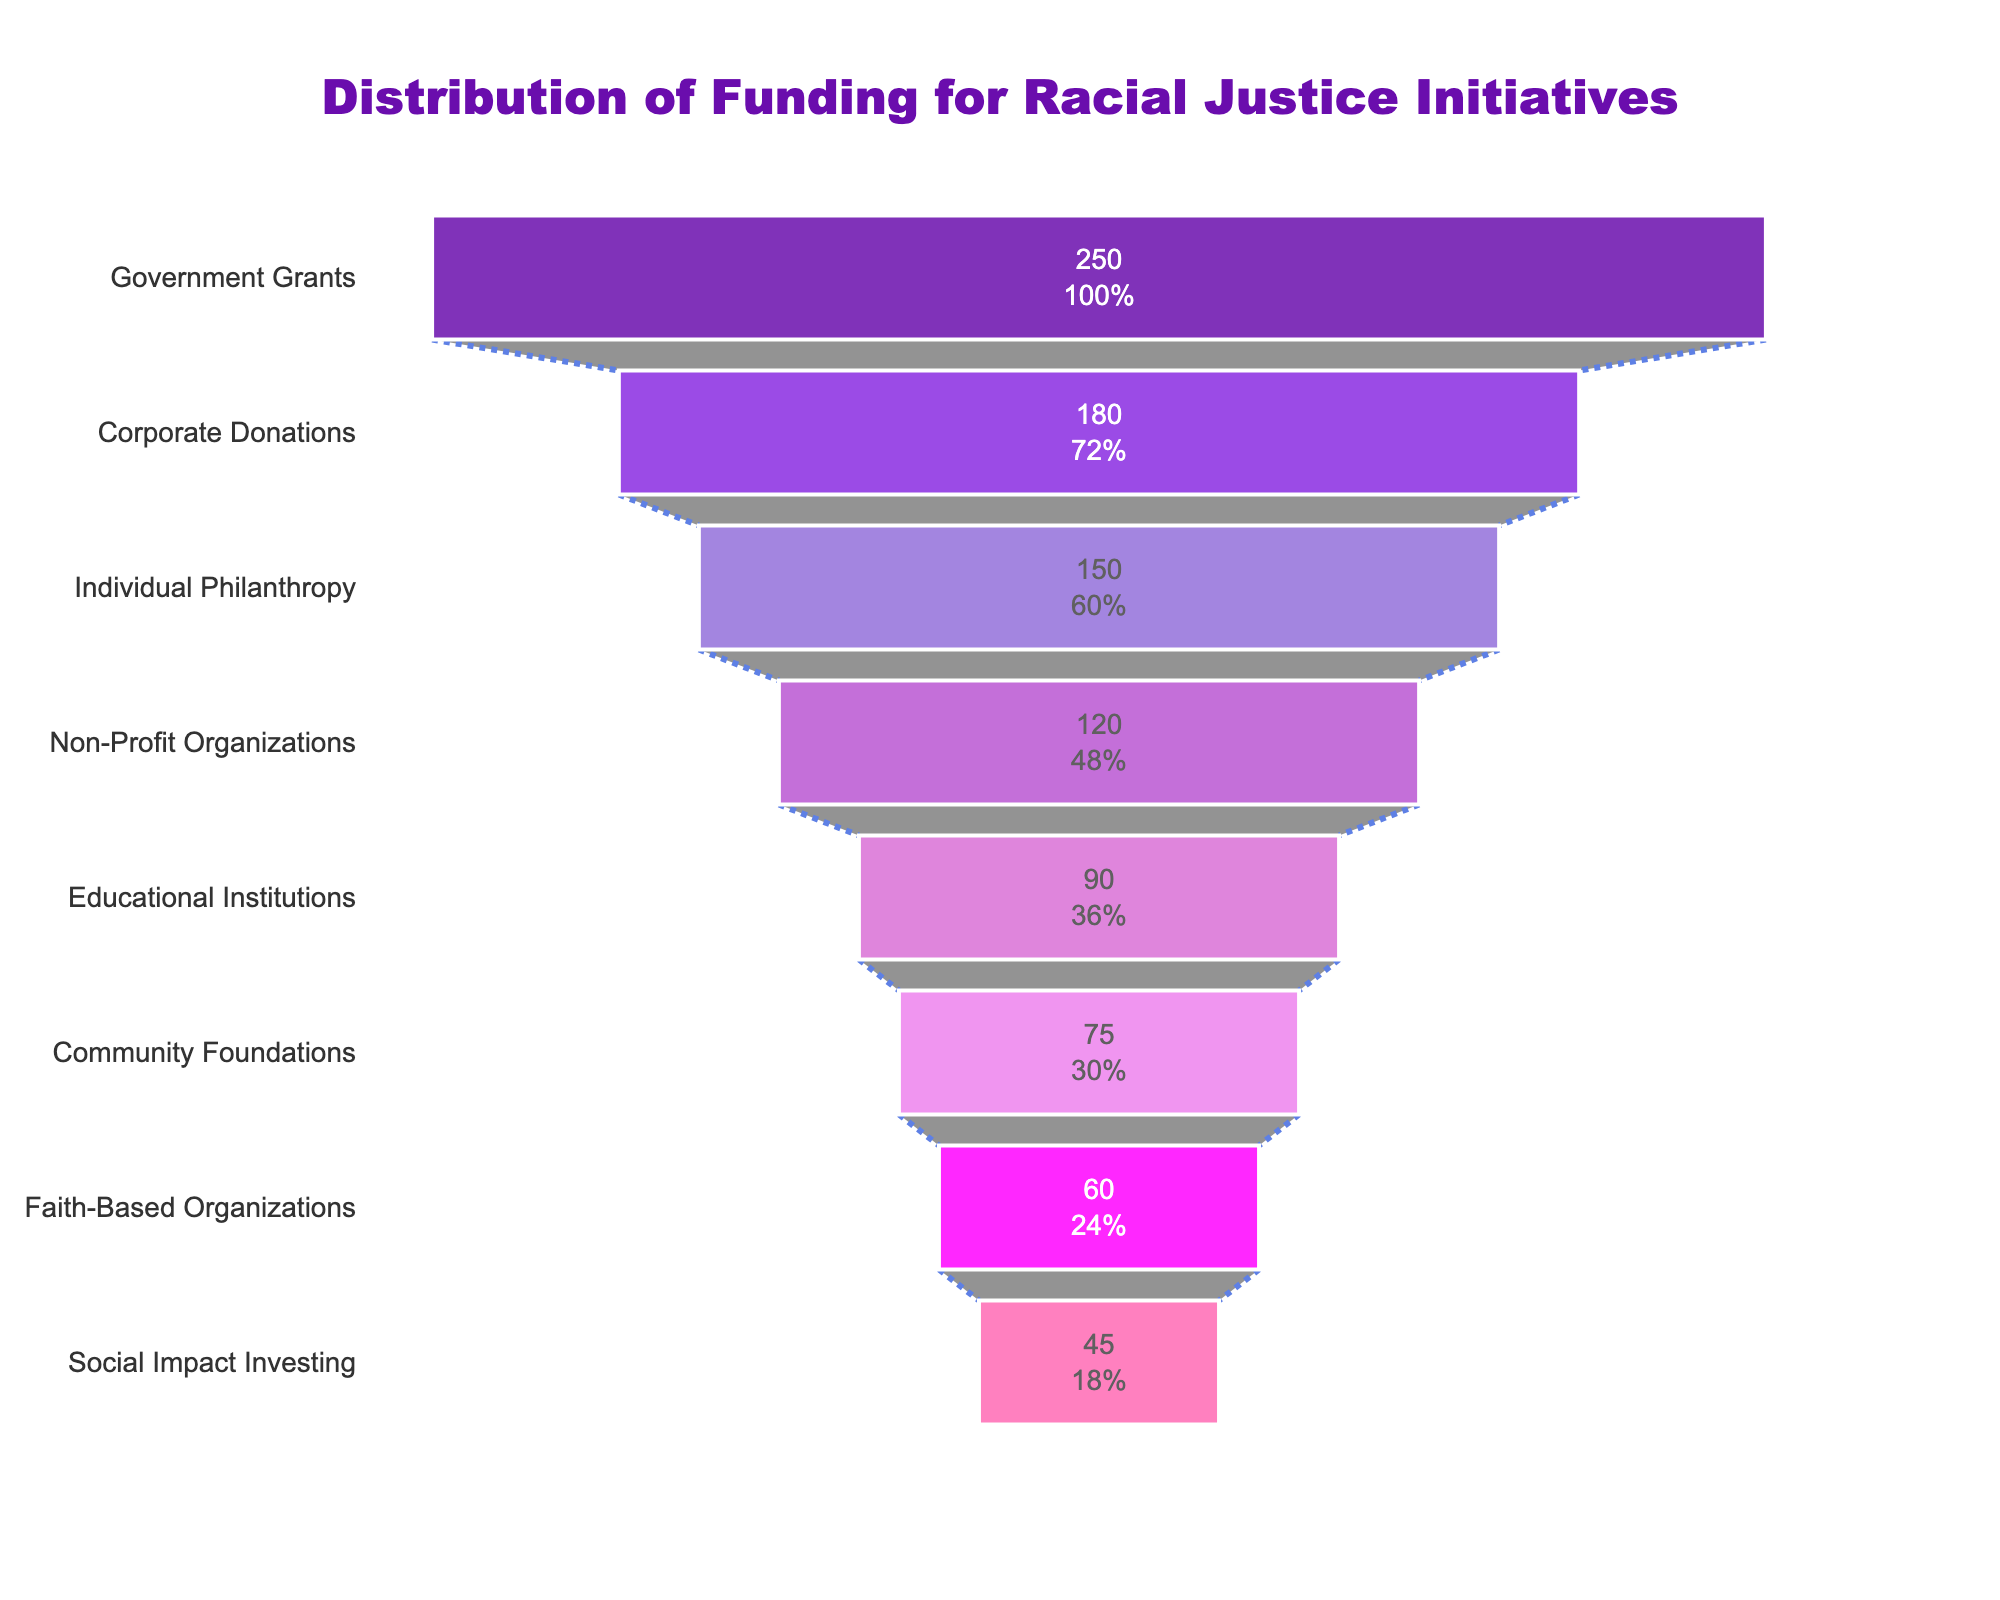What is the title of the funnel chart? The title can be read directly at the top of the chart. It states the main focus of the visualization.
Answer: Distribution of Funding for Racial Justice Initiatives Which sector received the highest amount of funding? By looking at the funnel chart from top to bottom, the sector at the very top represents the highest funding.
Answer: Government Grants How much total funding is represented in the chart? Sum the funding amounts of all sectors shown in the chart: 250 + 180 + 150 + 120 + 90 + 75 + 60 + 45.
Answer: 970 Million USD What percentage of the total funding does the Corporate Donations sector represent? First, identify the funding amount for Corporate Donations (180 Million USD). Then divide it by the total funding (970 Million USD) and multiply by 100 to get the percentage: (180/970) * 100.
Answer: Approximately 18.56% Which sector received less funding than Non-Profit Organizations but more than Faith-Based Organizations? Look at the order in the funnel chart; Non-Profit Organizations received 120 Million USD, and Faith-Based Organizations received 60 Million USD. Identify the sector that lies between these, which is Educational Institutions.
Answer: Educational Institutions How much more funding did Individual Philanthropy receive compared to Social Impact Investing? Find the difference between the funding amounts for these sectors: Individual Philanthropy (150 Million USD) and Social Impact Investing (45 Million USD). Subtract 45 from 150.
Answer: 105 Million USD Which sector has the smallest segment in the funnel chart? The smallest segment in the funnel chart is at the very bottom, representing the sector with the least funding.
Answer: Social Impact Investing What is the combined funding amount for Community Foundations and Faith-Based Organizations? Add the funding for these two sectors: Community Foundations (75 Million USD) and Faith-Based Organizations (60 Million USD).
Answer: 135 Million USD How many sectors have a funding amount greater than 100 Million USD? Count the number of sectors in the chart with funding amounts above 100 Million USD: Government Grants, Corporate Donations, Individual Philanthropy, Non-Profit Organizations.
Answer: 4 sectors 